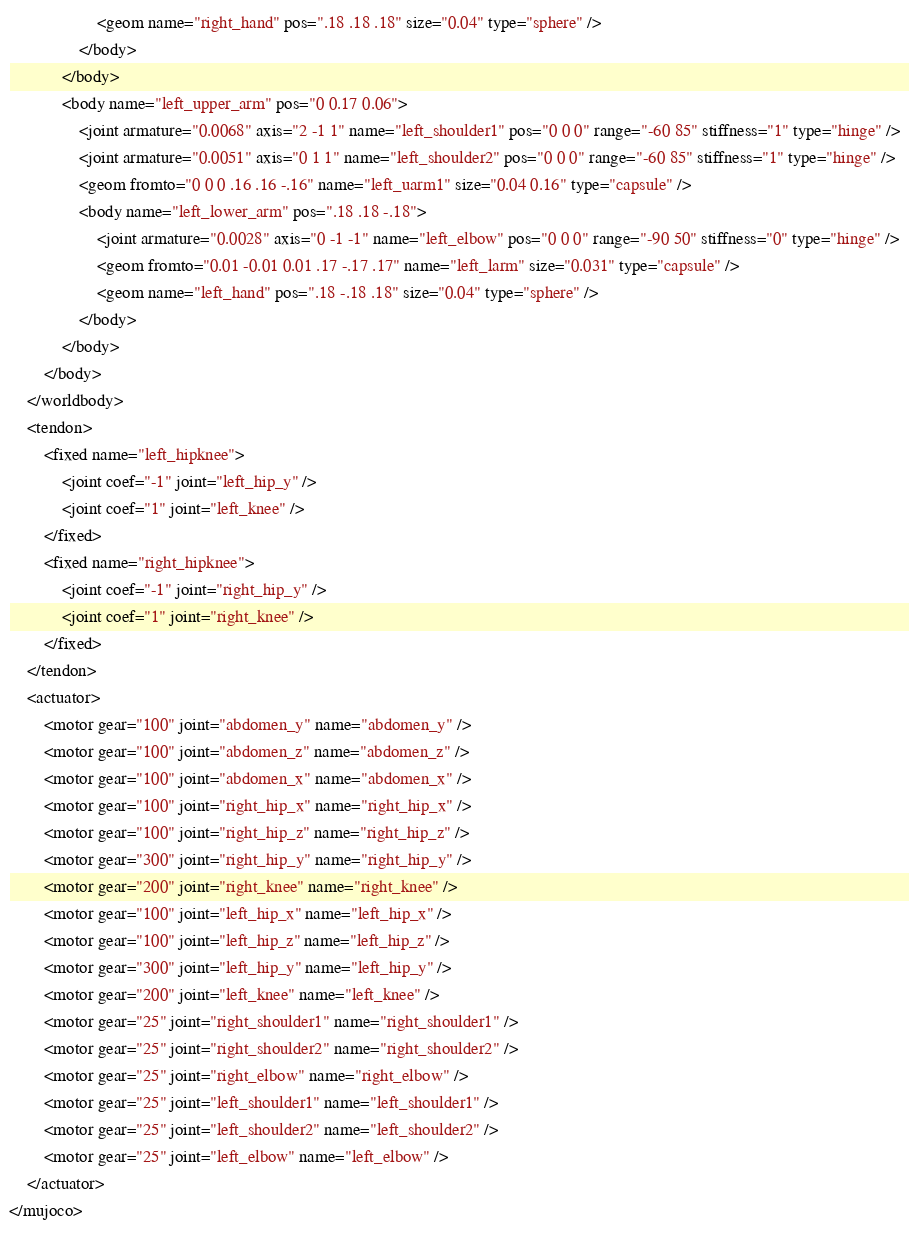<code> <loc_0><loc_0><loc_500><loc_500><_XML_>                    <geom name="right_hand" pos=".18 .18 .18" size="0.04" type="sphere" />
                </body>
            </body>
            <body name="left_upper_arm" pos="0 0.17 0.06">
                <joint armature="0.0068" axis="2 -1 1" name="left_shoulder1" pos="0 0 0" range="-60 85" stiffness="1" type="hinge" />
                <joint armature="0.0051" axis="0 1 1" name="left_shoulder2" pos="0 0 0" range="-60 85" stiffness="1" type="hinge" />
                <geom fromto="0 0 0 .16 .16 -.16" name="left_uarm1" size="0.04 0.16" type="capsule" />
                <body name="left_lower_arm" pos=".18 .18 -.18">
                    <joint armature="0.0028" axis="0 -1 -1" name="left_elbow" pos="0 0 0" range="-90 50" stiffness="0" type="hinge" />
                    <geom fromto="0.01 -0.01 0.01 .17 -.17 .17" name="left_larm" size="0.031" type="capsule" />
                    <geom name="left_hand" pos=".18 -.18 .18" size="0.04" type="sphere" />
                </body>
            </body>
        </body>
    </worldbody>
    <tendon>
        <fixed name="left_hipknee">
            <joint coef="-1" joint="left_hip_y" />
            <joint coef="1" joint="left_knee" />
        </fixed>
        <fixed name="right_hipknee">
            <joint coef="-1" joint="right_hip_y" />
            <joint coef="1" joint="right_knee" />
        </fixed>
    </tendon>
    <actuator>
        <motor gear="100" joint="abdomen_y" name="abdomen_y" />
        <motor gear="100" joint="abdomen_z" name="abdomen_z" />
        <motor gear="100" joint="abdomen_x" name="abdomen_x" />
        <motor gear="100" joint="right_hip_x" name="right_hip_x" />
        <motor gear="100" joint="right_hip_z" name="right_hip_z" />
        <motor gear="300" joint="right_hip_y" name="right_hip_y" />
        <motor gear="200" joint="right_knee" name="right_knee" />
        <motor gear="100" joint="left_hip_x" name="left_hip_x" />
        <motor gear="100" joint="left_hip_z" name="left_hip_z" />
        <motor gear="300" joint="left_hip_y" name="left_hip_y" />
        <motor gear="200" joint="left_knee" name="left_knee" />
        <motor gear="25" joint="right_shoulder1" name="right_shoulder1" />
        <motor gear="25" joint="right_shoulder2" name="right_shoulder2" />
        <motor gear="25" joint="right_elbow" name="right_elbow" />
        <motor gear="25" joint="left_shoulder1" name="left_shoulder1" />
        <motor gear="25" joint="left_shoulder2" name="left_shoulder2" />
        <motor gear="25" joint="left_elbow" name="left_elbow" />
    </actuator>
</mujoco></code> 